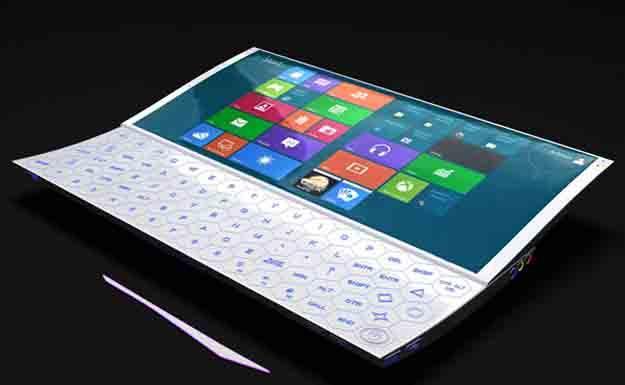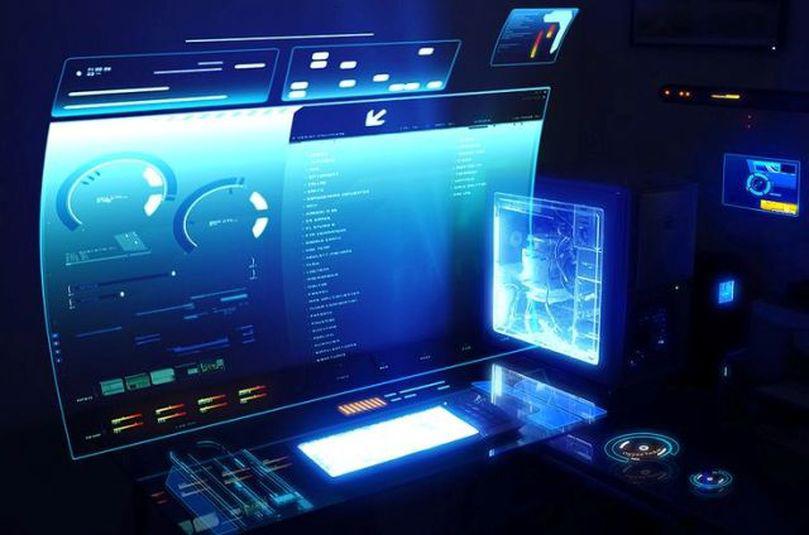The first image is the image on the left, the second image is the image on the right. For the images shown, is this caption "The laptop on the right has a slightly curved, concave screen." true? Answer yes or no. Yes. 